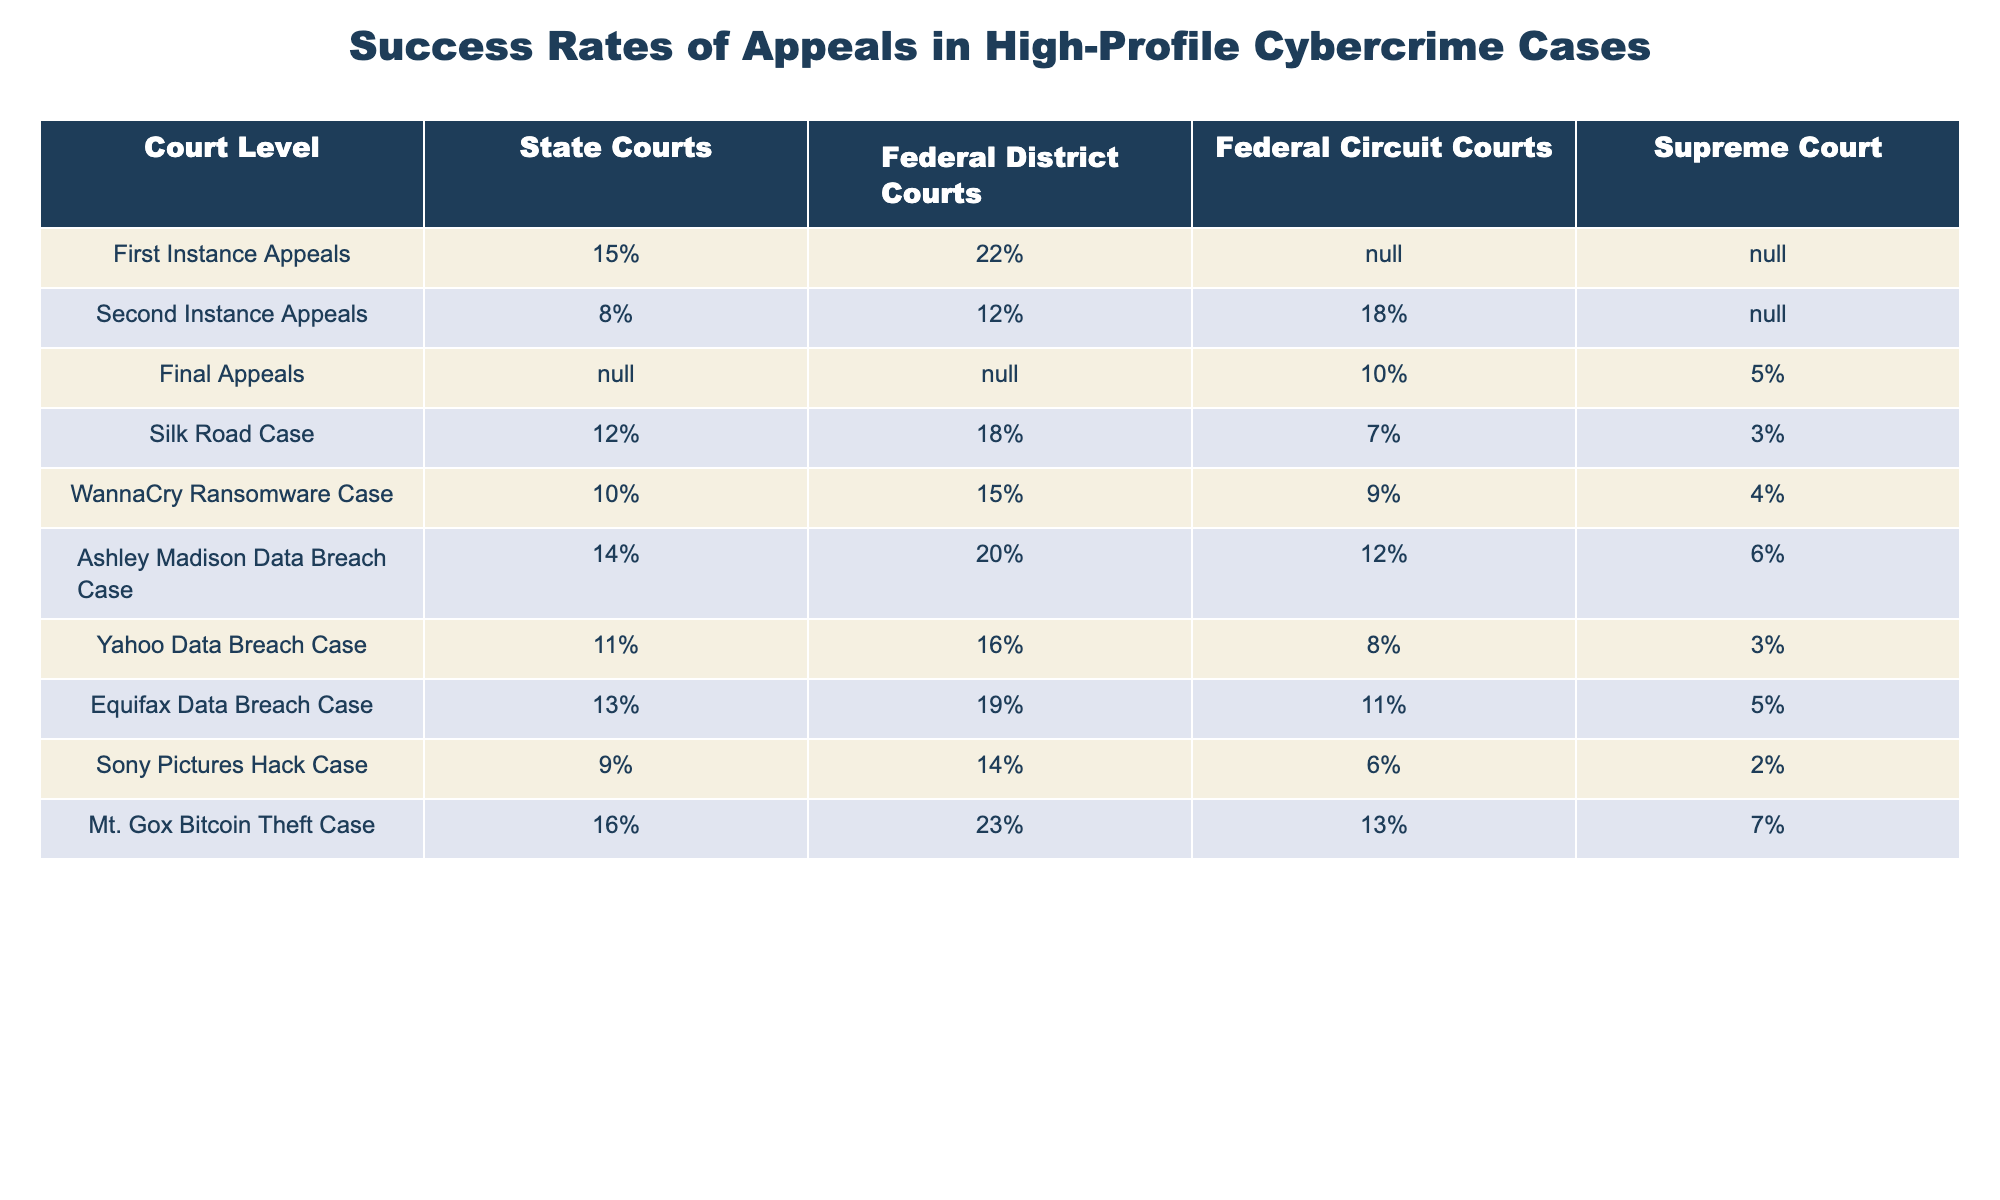What is the success rate of first instance appeals in Federal District Courts? According to the table, the success rate for first instance appeals in Federal District Courts is listed as 22%.
Answer: 22% Which high-profile cybercrime case had the highest success rate in Federal Circuit Courts? By examining the success rates for high-profile cases in the Federal Circuit Courts, the Mt. Gox Bitcoin Theft Case has the highest success rate at 13%.
Answer: 13% What is the average success rate of final appeals across all court levels provided in the table? The final appeal success rates are available under Federal Circuit Courts (10%) and Supreme Court (5%). Adding these gives 10 + 5 = 15%. With 2 court levels, the average is 15% / 2 = 7.5%.
Answer: 7.5% Is it true that the success rate for the Ashley Madison Data Breach Case is higher in State Courts than in Federal District Courts? Looking at the success rates, the Ashley Madison Data Breach Case shows 14% in State Courts and 20% in Federal District Courts, which means the statement is false.
Answer: No What is the difference in success rates between the Silk Road Case and the WannaCry Ransomware Case in Federal District Courts? The Silk Road Case has a success rate of 18% in Federal District Courts and the WannaCry Ransomware Case has 15%. The difference is 18% - 15% = 3%.
Answer: 3% 